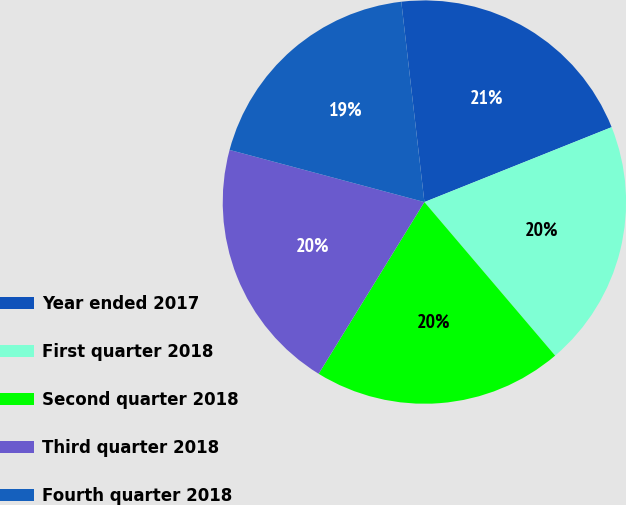<chart> <loc_0><loc_0><loc_500><loc_500><pie_chart><fcel>Year ended 2017<fcel>First quarter 2018<fcel>Second quarter 2018<fcel>Third quarter 2018<fcel>Fourth quarter 2018<nl><fcel>20.77%<fcel>19.83%<fcel>20.01%<fcel>20.38%<fcel>19.01%<nl></chart> 